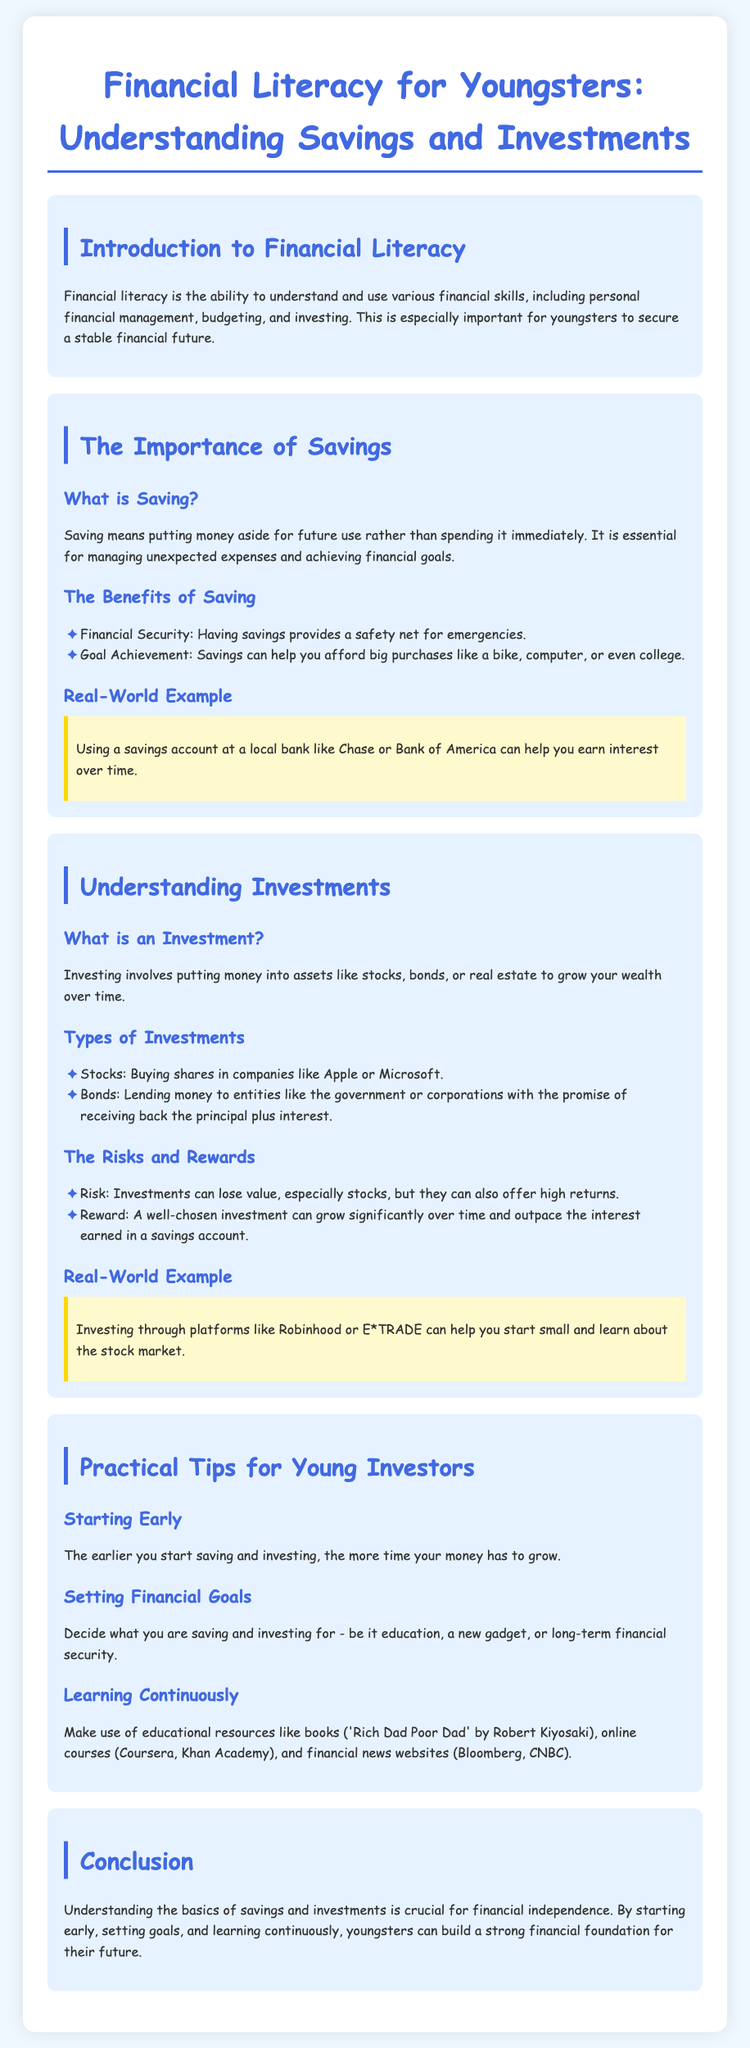What is the title of the lesson plan? The title of the lesson plan is provided at the top of the document.
Answer: Financial Literacy for Youngsters: Understanding Savings and Investments What is saving? The definition of saving is mentioned under the importance of savings section.
Answer: Putting money aside for future use What are two benefits of saving? The benefits of saving are listed in a bullet format in the document.
Answer: Financial Security and Goal Achievement What is an investment? The definition of investment is detailed in the section on understanding investments.
Answer: Putting money into assets to grow wealth Name one type of investment mentioned in the document. The document lists various types of investments, one of which is specified.
Answer: Stocks What risk is associated with stocks? The risks and rewards section highlights the risks involved with investments.
Answer: Can lose value What is one practical tip for young investors? The document provides tips for young investors, one of which is specified.
Answer: Starting Early Which book is recommended for learning about financial literacy? The document mentions specific resources for learning, including books.
Answer: Rich Dad Poor Dad What is the main conclusion of the lesson plan? The last section summarizes the importance of the lessons covered.
Answer: Crucial for financial independence 